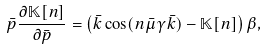Convert formula to latex. <formula><loc_0><loc_0><loc_500><loc_500>\bar { p } \frac { \partial \mathbb { K } [ n ] } { \partial \bar { p } } = \left ( \bar { k } \cos ( n \bar { \mu } \gamma \bar { k } ) - \mathbb { K } [ n ] \right ) \beta ,</formula> 